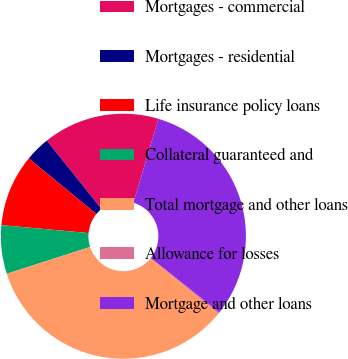<chart> <loc_0><loc_0><loc_500><loc_500><pie_chart><fcel>Mortgages - commercial<fcel>Mortgages - residential<fcel>Life insurance policy loans<fcel>Collateral guaranteed and<fcel>Total mortgage and other loans<fcel>Allowance for losses<fcel>Mortgage and other loans<nl><fcel>15.37%<fcel>3.29%<fcel>9.51%<fcel>6.4%<fcel>34.18%<fcel>0.19%<fcel>31.07%<nl></chart> 